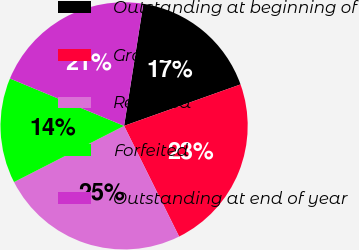Convert chart to OTSL. <chart><loc_0><loc_0><loc_500><loc_500><pie_chart><fcel>Outstanding at beginning of<fcel>Granted<fcel>Released<fcel>Forfeited<fcel>Outstanding at end of year<nl><fcel>17.07%<fcel>23.1%<fcel>24.83%<fcel>13.77%<fcel>21.23%<nl></chart> 